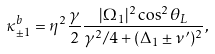Convert formula to latex. <formula><loc_0><loc_0><loc_500><loc_500>\kappa _ { \pm 1 } ^ { b } = \eta ^ { 2 } \frac { \gamma } { 2 } \frac { | \Omega _ { 1 } | ^ { 2 } \cos ^ { 2 } \theta _ { L } } { \gamma ^ { 2 } / 4 + ( \Delta _ { 1 } \pm \nu ^ { \prime } ) ^ { 2 } } ,</formula> 